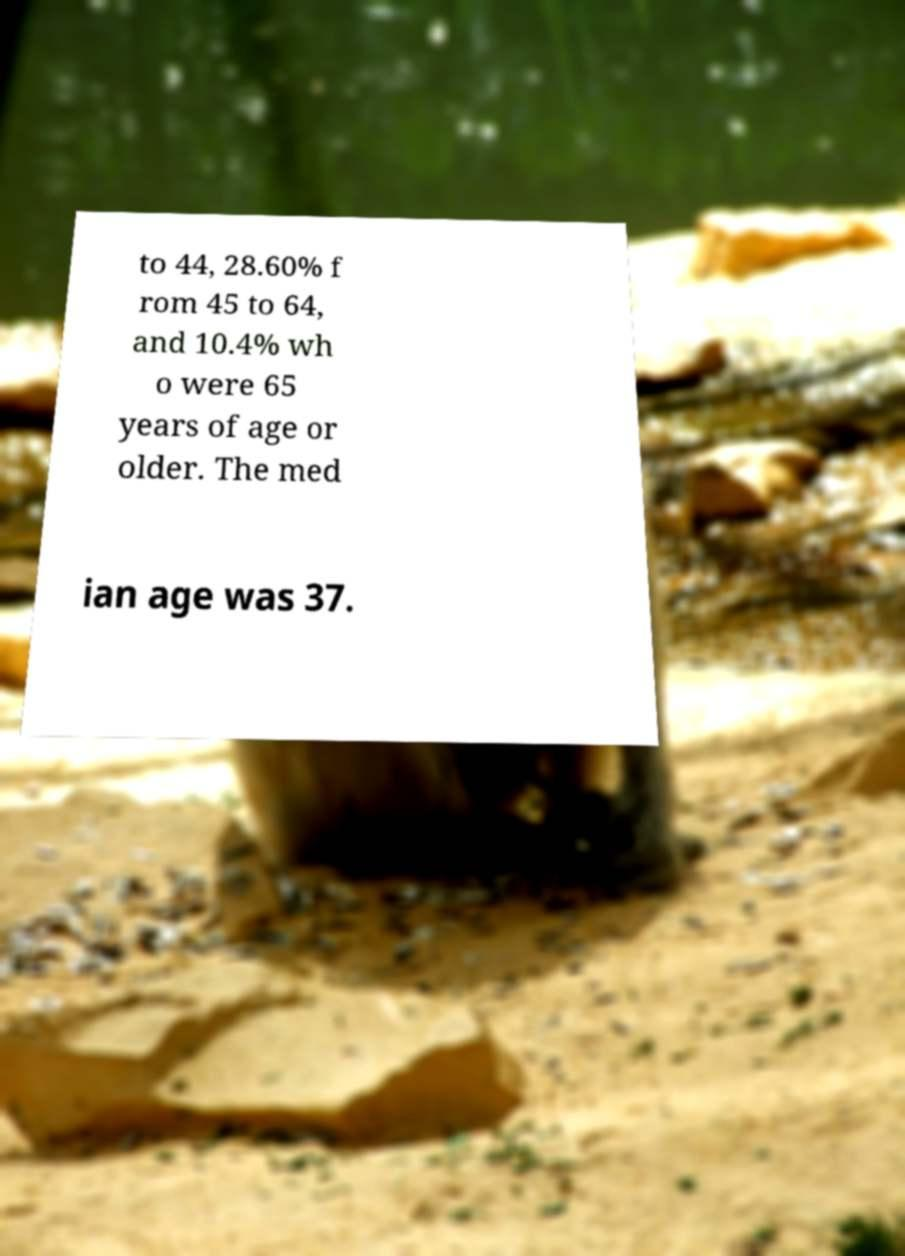There's text embedded in this image that I need extracted. Can you transcribe it verbatim? to 44, 28.60% f rom 45 to 64, and 10.4% wh o were 65 years of age or older. The med ian age was 37. 